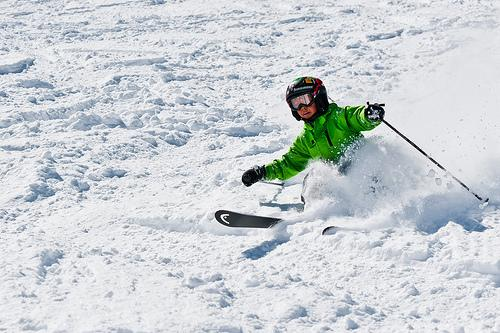Write about the details of the skier's outfit and accessories. The skier is wearing a green jacket with a black zipper, a colorful helmet, black gloves, and black goggles, amidst the snowy landscape. Illustrate the emotions felt by the viewer when observing the image. The image evokes a sense of excitement and adventure, as the skier in the green jacket conquers the snowy slopes with his ski poles for balance. Mention what the skier is wearing and their current action. The skier is wearing a green jacket, a colorful helmet, black goggles, and black gloves while skiing downhill and being partially buried in snow. Give an overview of the color scheme seen in the image. The image mainly features white snow, a skier wearing a green jacket, black goggles, a colorful helmet, and holding black ski poles. Mention how the skier is interacting with the snow and equipment. The skier is partially buried in snow, skiing with one ski visible, and holding black ski poles to maintain balance while wearing a helmet and goggles. Explain what is happening with the skier's equipment. One of the skier's skis is sticking out of the snow, and he uses his black metal ski poles to balance. The ski's white symbol and black bottom are visible. Share the key aspects of the image involving the skier and their surroundings. The image captures a skier wearing a green jacket and colorful helmet skiing down a snowy slope with sun shining, ski poles in hand, and snow flying around. Describe the skier's movement and posture. The skier is skiing downhill while maintaining balance by holding his ski poles, with one of his skis partially buried in the snow. Describe the environment and weather conditions in the image. The image shows a snowy, messy landscape with a skier taking on slopes under the shining sun, creating a shadow on the ground. Provide a brief summary of the scene captured in the image. A skier in a green jacket and goggles is skiing down a snowy slope, with his ski poles helping him balance and one ski sticking out of the snow. 